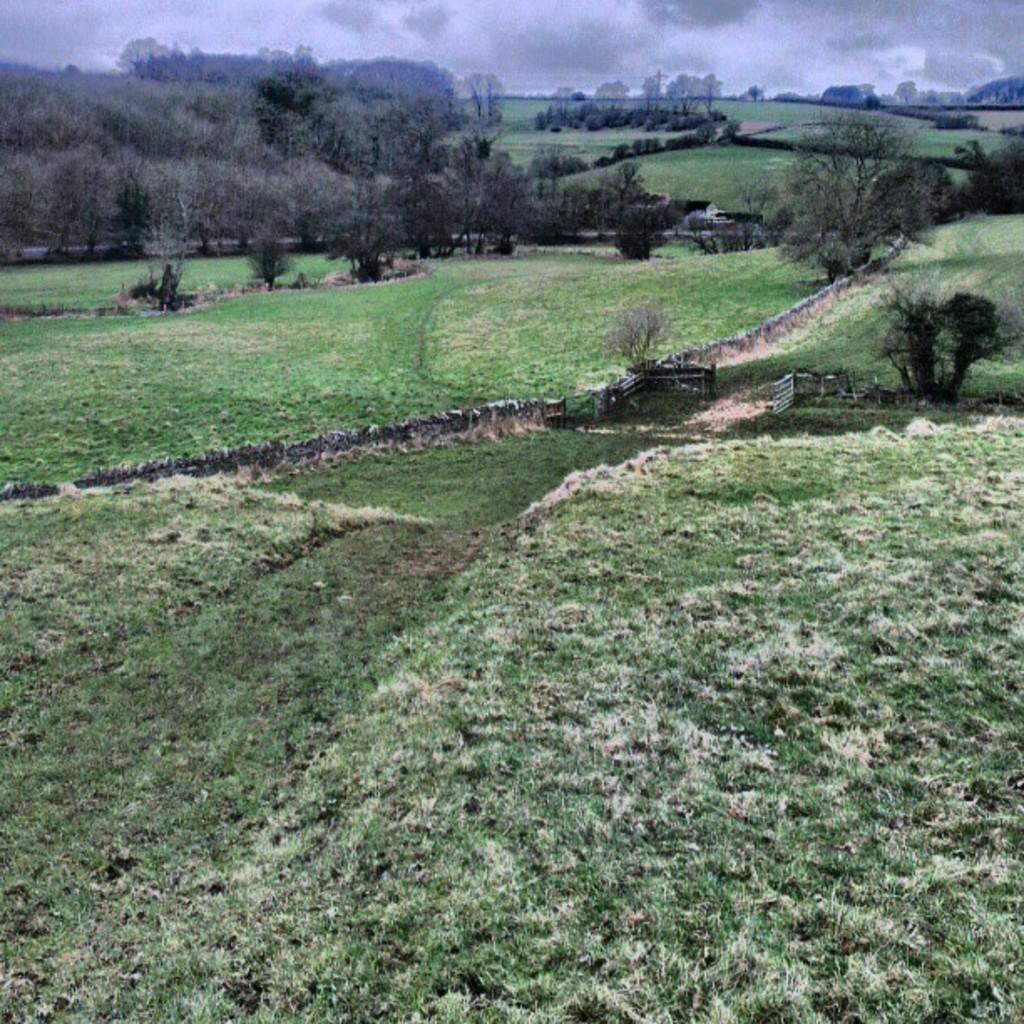Please provide a concise description of this image. In this image I can see the grass on the ground. In the background I can see many trees, clouds and the sky. 